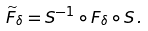<formula> <loc_0><loc_0><loc_500><loc_500>\widetilde { F } _ { \delta } = S ^ { - 1 } \circ F _ { \delta } \circ S \, .</formula> 